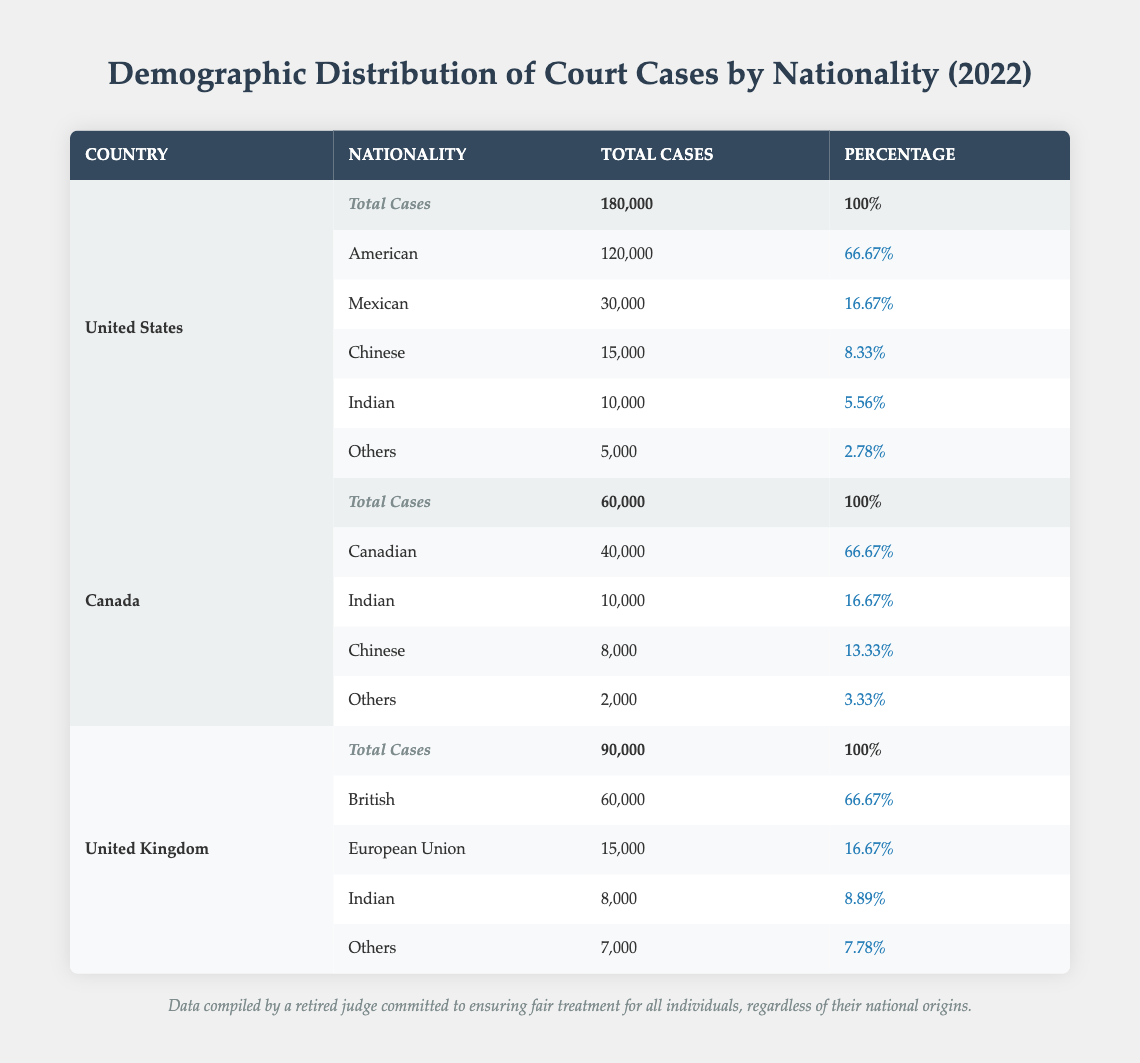What is the total number of court cases in the United States in 2022? The total number of court cases in the United States is clearly stated in the "Total Cases" row under the United States section, which shows 180,000.
Answer: 180,000 What percentage of court cases in Canada were Canadian? In the Canada section, the row for Canadian nationality indicates that 66.67% of the total cases were Canadian, which is listed directly in the table.
Answer: 66.67% How many cases were filed by Indian nationals in the United Kingdom? The table shows that Indian nationals filed 8,000 cases in the United Kingdom, which is directly mentioned in the UK section under Indian nationality.
Answer: 8,000 What is the difference in the total number of cases between the United States and Canada? The total cases for the United States is 180,000 and for Canada is 60,000. The difference is calculated as 180,000 - 60,000 equals 120,000.
Answer: 120,000 Did the United Kingdom have more cases filed by Europeans than Indians? In the UK section, 15,000 cases were filed by Europeans while 8,000 cases were filed by Indians. Therefore, yes, the number of cases filed by Europeans is greater than that of Indians.
Answer: Yes What is the total number of cases filed by "Others" in the United States, Canada, and the United Kingdom combined? The "Others" category has 5,000 cases in the United States, 2,000 in Canada, and 7,000 in the United Kingdom. Adding these up, we get 5,000 + 2,000 + 7,000 = 14,000.
Answer: 14,000 What nationality represented the smallest percentage of court cases in the United States? In the United States section, "Others" is the category with the smallest percentage of cases filed, showing 2.78%.
Answer: Others How many total cases were filed in North America (United States and Canada) by American nationals? The United States had 120,000 American cases and Canada had no cases filed by Americans (not listed). The total cases filed by American nationals is 120,000.
Answer: 120,000 What is the average percentage of cases filed by Indian nationals across the three countries? The United States had 5.56%, Canada had 16.67%, and the United Kingdom had 8.89%. To find the average: (5.56 + 16.67 + 8.89) / 3 equals 10.04%.
Answer: 10.04% 